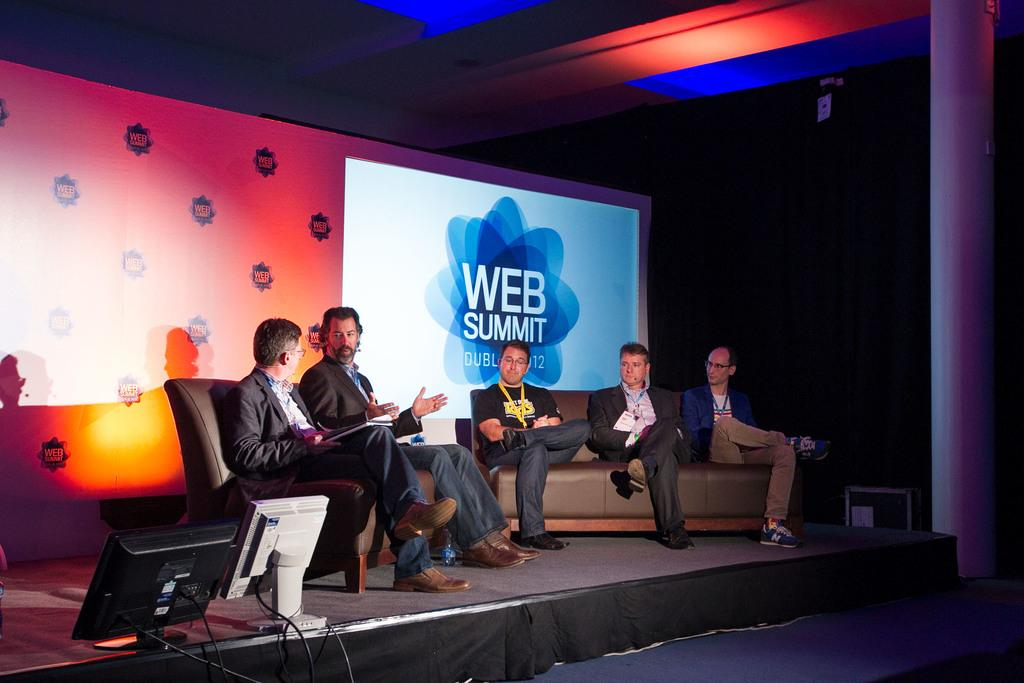What are the people in the image doing? There are people sitting on a couch in the image. What can be seen on the stage in the image? There are two systems on a stage in the image. What is the colorful object visible in the image? There is a colorful screen visible in the image. How many police officers are visible in the image? There are no police officers present in the image. What type of patch is sewn onto the hand of the person sitting on the couch? There is no patch or person with a visible hand in the image. 